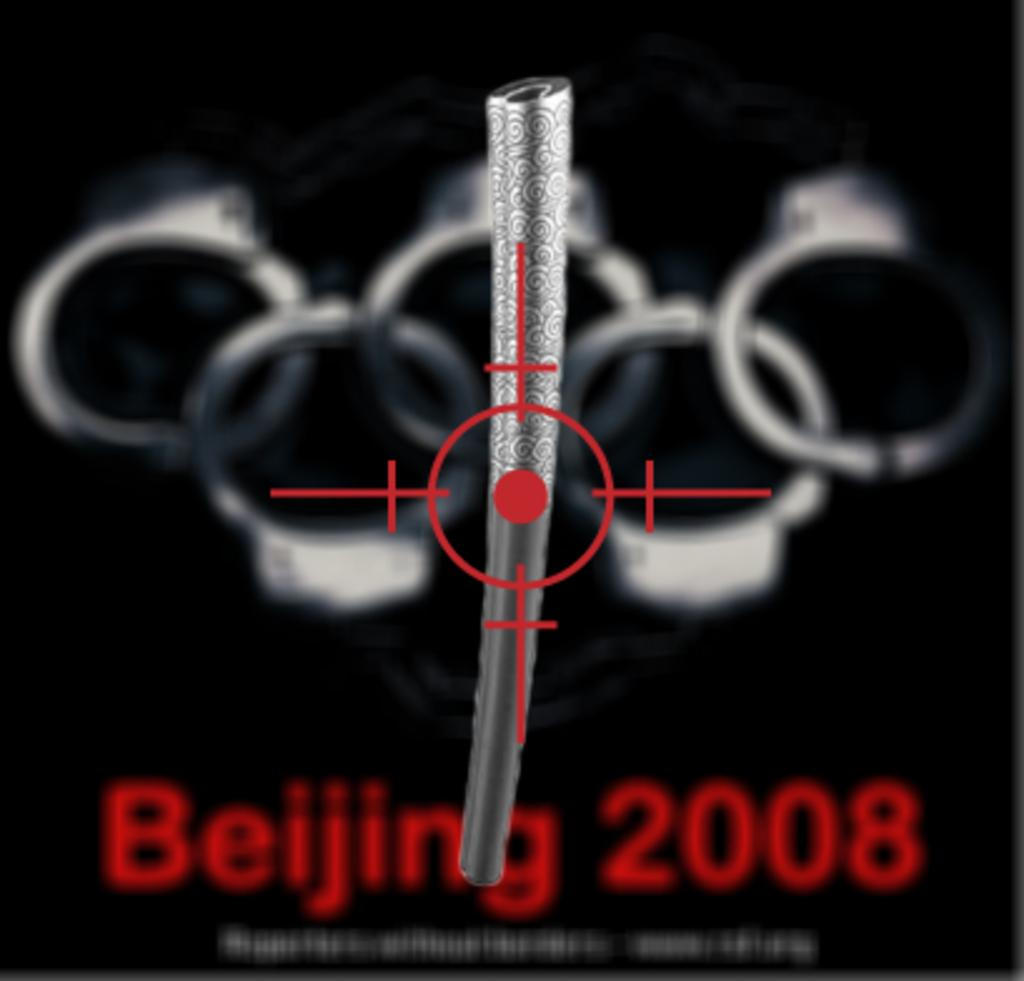Provide a one-sentence caption for the provided image. Beijing 2008 sign on a paper with handcuffs in the background. 